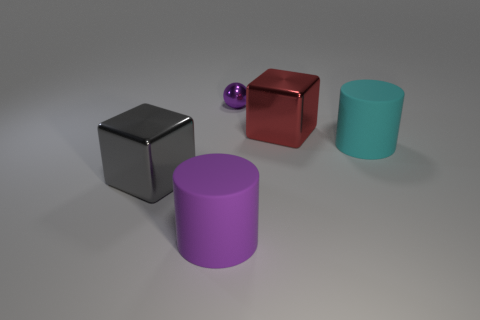How many metallic things are either cylinders or large cyan objects?
Offer a terse response. 0. Is there a gray block of the same size as the purple rubber cylinder?
Make the answer very short. Yes. Is the number of large things to the right of the big purple rubber cylinder greater than the number of gray rubber balls?
Make the answer very short. Yes. How many big objects are either matte cylinders or red objects?
Provide a succinct answer. 3. How many other objects are the same shape as the large cyan matte thing?
Provide a succinct answer. 1. There is a big cylinder that is to the right of the big block behind the gray object; what is it made of?
Provide a short and direct response. Rubber. What is the size of the object in front of the large gray metallic object?
Ensure brevity in your answer.  Large. How many yellow things are tiny metal balls or big metal objects?
Keep it short and to the point. 0. What is the material of the other large thing that is the same shape as the cyan matte object?
Offer a terse response. Rubber. Are there the same number of big cylinders that are in front of the cyan cylinder and big rubber objects?
Your answer should be very brief. No. 